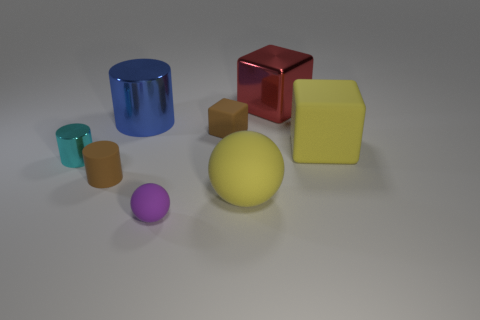Is there a red metallic object behind the large shiny object that is on the left side of the small matte thing that is behind the yellow matte cube?
Your answer should be compact. Yes. The large yellow object that is made of the same material as the yellow sphere is what shape?
Keep it short and to the point. Cube. Is the number of big red metallic things greater than the number of large gray matte cylinders?
Make the answer very short. Yes. There is a large blue thing; does it have the same shape as the small thing that is on the right side of the purple sphere?
Keep it short and to the point. No. What material is the yellow ball?
Your answer should be very brief. Rubber. What is the color of the large block behind the metallic cylinder that is behind the metal thing that is in front of the yellow cube?
Offer a terse response. Red. There is a yellow thing that is the same shape as the purple thing; what material is it?
Make the answer very short. Rubber. What number of cyan shiny things are the same size as the red metal block?
Provide a short and direct response. 0. What number of large shiny balls are there?
Offer a very short reply. 0. Is the small cyan cylinder made of the same material as the brown object left of the tiny rubber sphere?
Offer a terse response. No. 